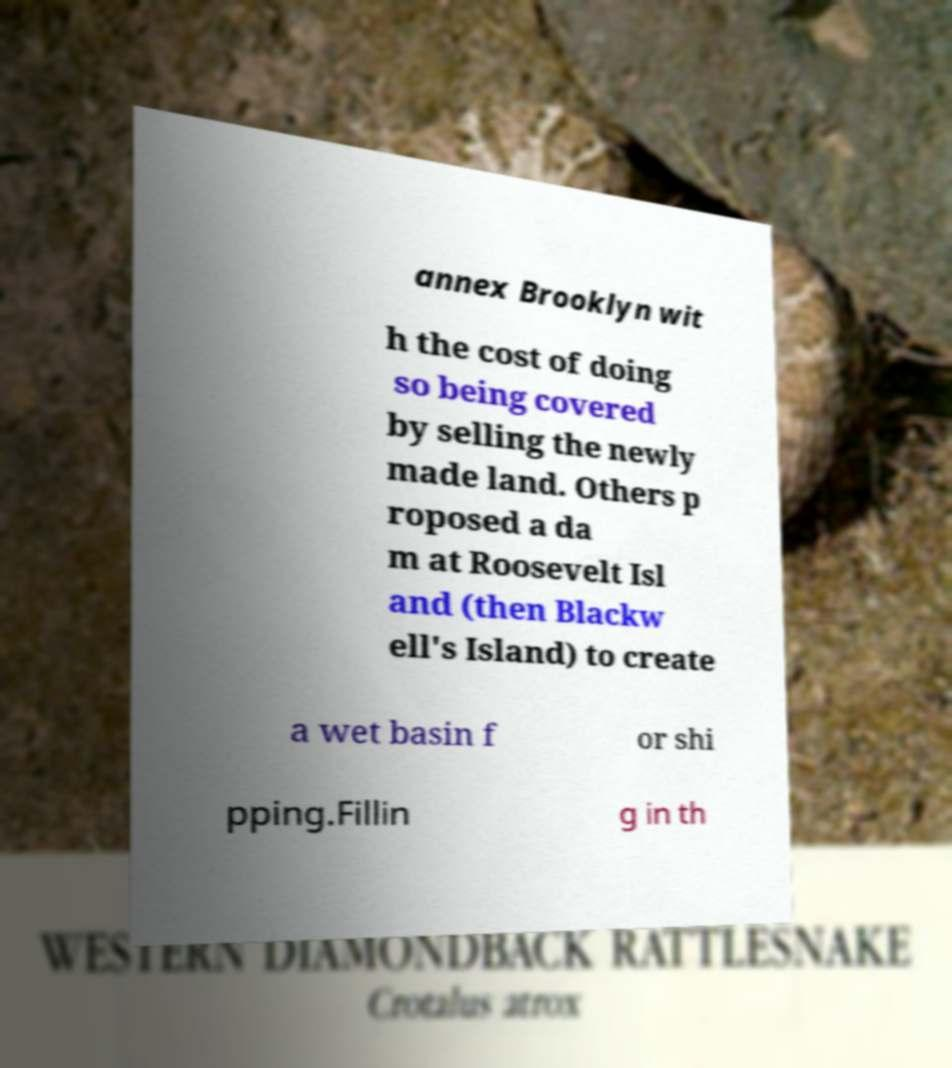I need the written content from this picture converted into text. Can you do that? annex Brooklyn wit h the cost of doing so being covered by selling the newly made land. Others p roposed a da m at Roosevelt Isl and (then Blackw ell's Island) to create a wet basin f or shi pping.Fillin g in th 